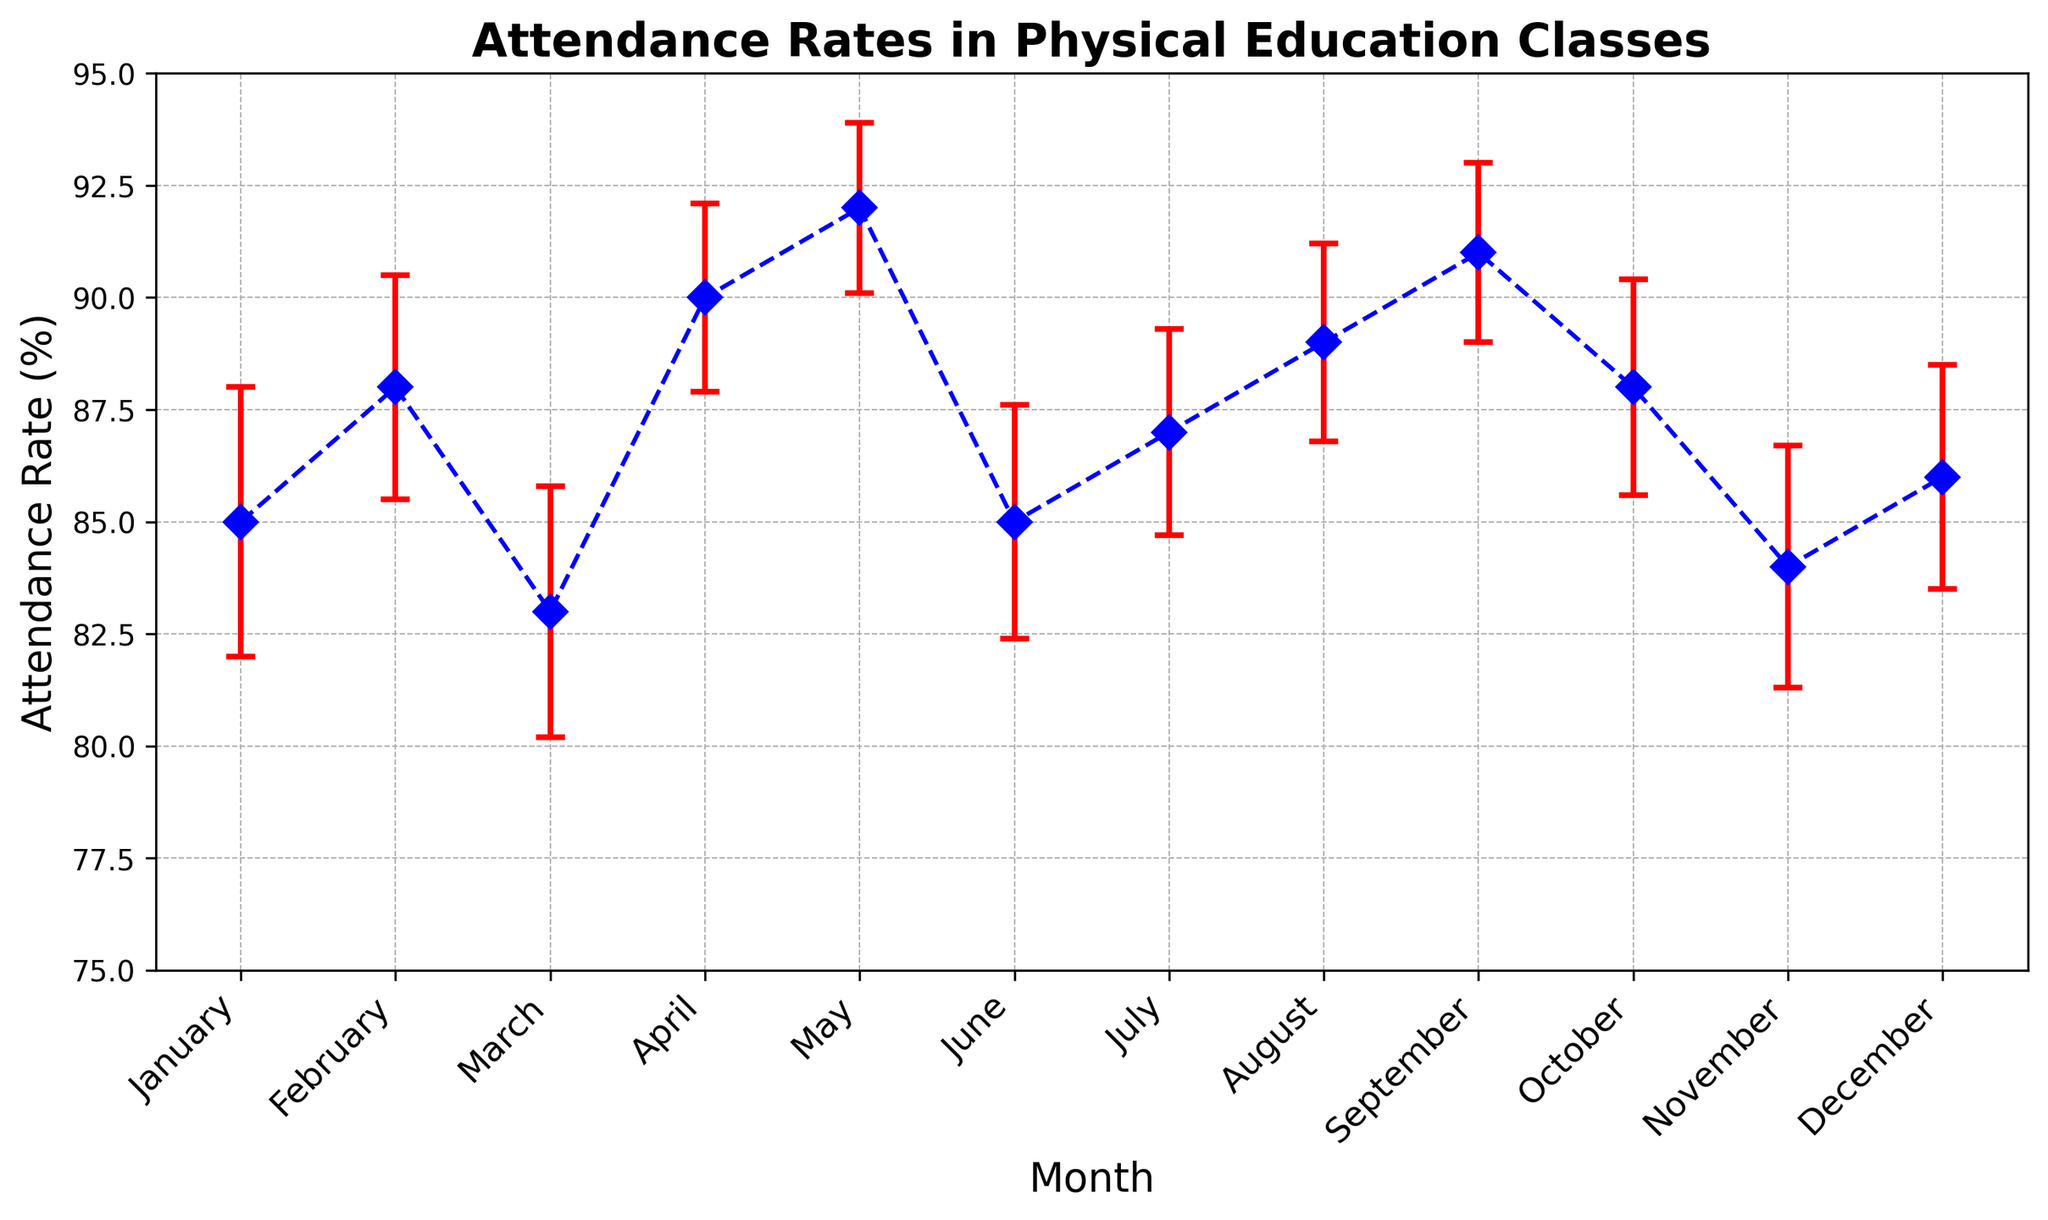How does the attendance rate in February compare to the rate in January? To determine this, look at the attendance rates for both months. February has a rate of 88% and January has a rate of 85%. Comparing these values shows that February's rate is higher than January's rate by 3%.
Answer: February's rate is 3% higher than January's What is the average attendance rate from May to September? To find the average, sum the attendance rates from May to September (92 + 85 + 87 + 89 + 91). The total is 444. Then, divide by the number of months: 444 / 5 = 88.8%.
Answer: 88.8% Which month has the lowest attendance rate? By visually scanning the plot, identify the month with the lowest point. March has the lowest attendance rate at 83%.
Answer: March What is the total range of attendance rates observed throughout the year? Determine the difference between the highest and lowest attendance rates. The highest rate is 92% (May) and the lowest is 83% (March). The range is 92 - 83 = 9%.
Answer: 9% In which months are the attendance rates above 90%? By looking at the plot, identify months with rates above 90%. Both May and September have rates over 90%, at 92% and 91%, respectively.
Answer: May and September How does the average attendance rate in the first half of the year compare to the second half? Calculate the average for the first half: (85 + 88 + 83 + 90 + 92 + 85)/6 = 86.17%. For the second half: (87 + 89 + 91 + 88 + 84 + 86)/6 = 87.5%. The average in the second half is higher by 87.5 - 86.17 = 1.33%.
Answer: The second half is 1.33% higher What is the attendance rate in April with its error margin? Refer to the plot to find April’s rate and its standard error. April’s rate is 90% and the error margin is ±2.1%. Therefore, the attendance rate with its margin ranges between 87.9% and 92.1%.
Answer: 90% ± 2.1% Which months have standard error bars overlapping with May? May has an attendance rate of 92% with a standard error of ±1.9%. So, the range is 90.1% to 93.9%. Identify months overlapping this range. April (90 ± 2.1), August (89 ± 2.2), and September (91 ± 2.0) overlap with May.
Answer: April, August, and September How much does the attendance rate in June differ from its highest point in May? Compare the attendance rate of June (85%) to the highest point in May (92%). The difference is 92 - 85 = 7%.
Answer: 7% 